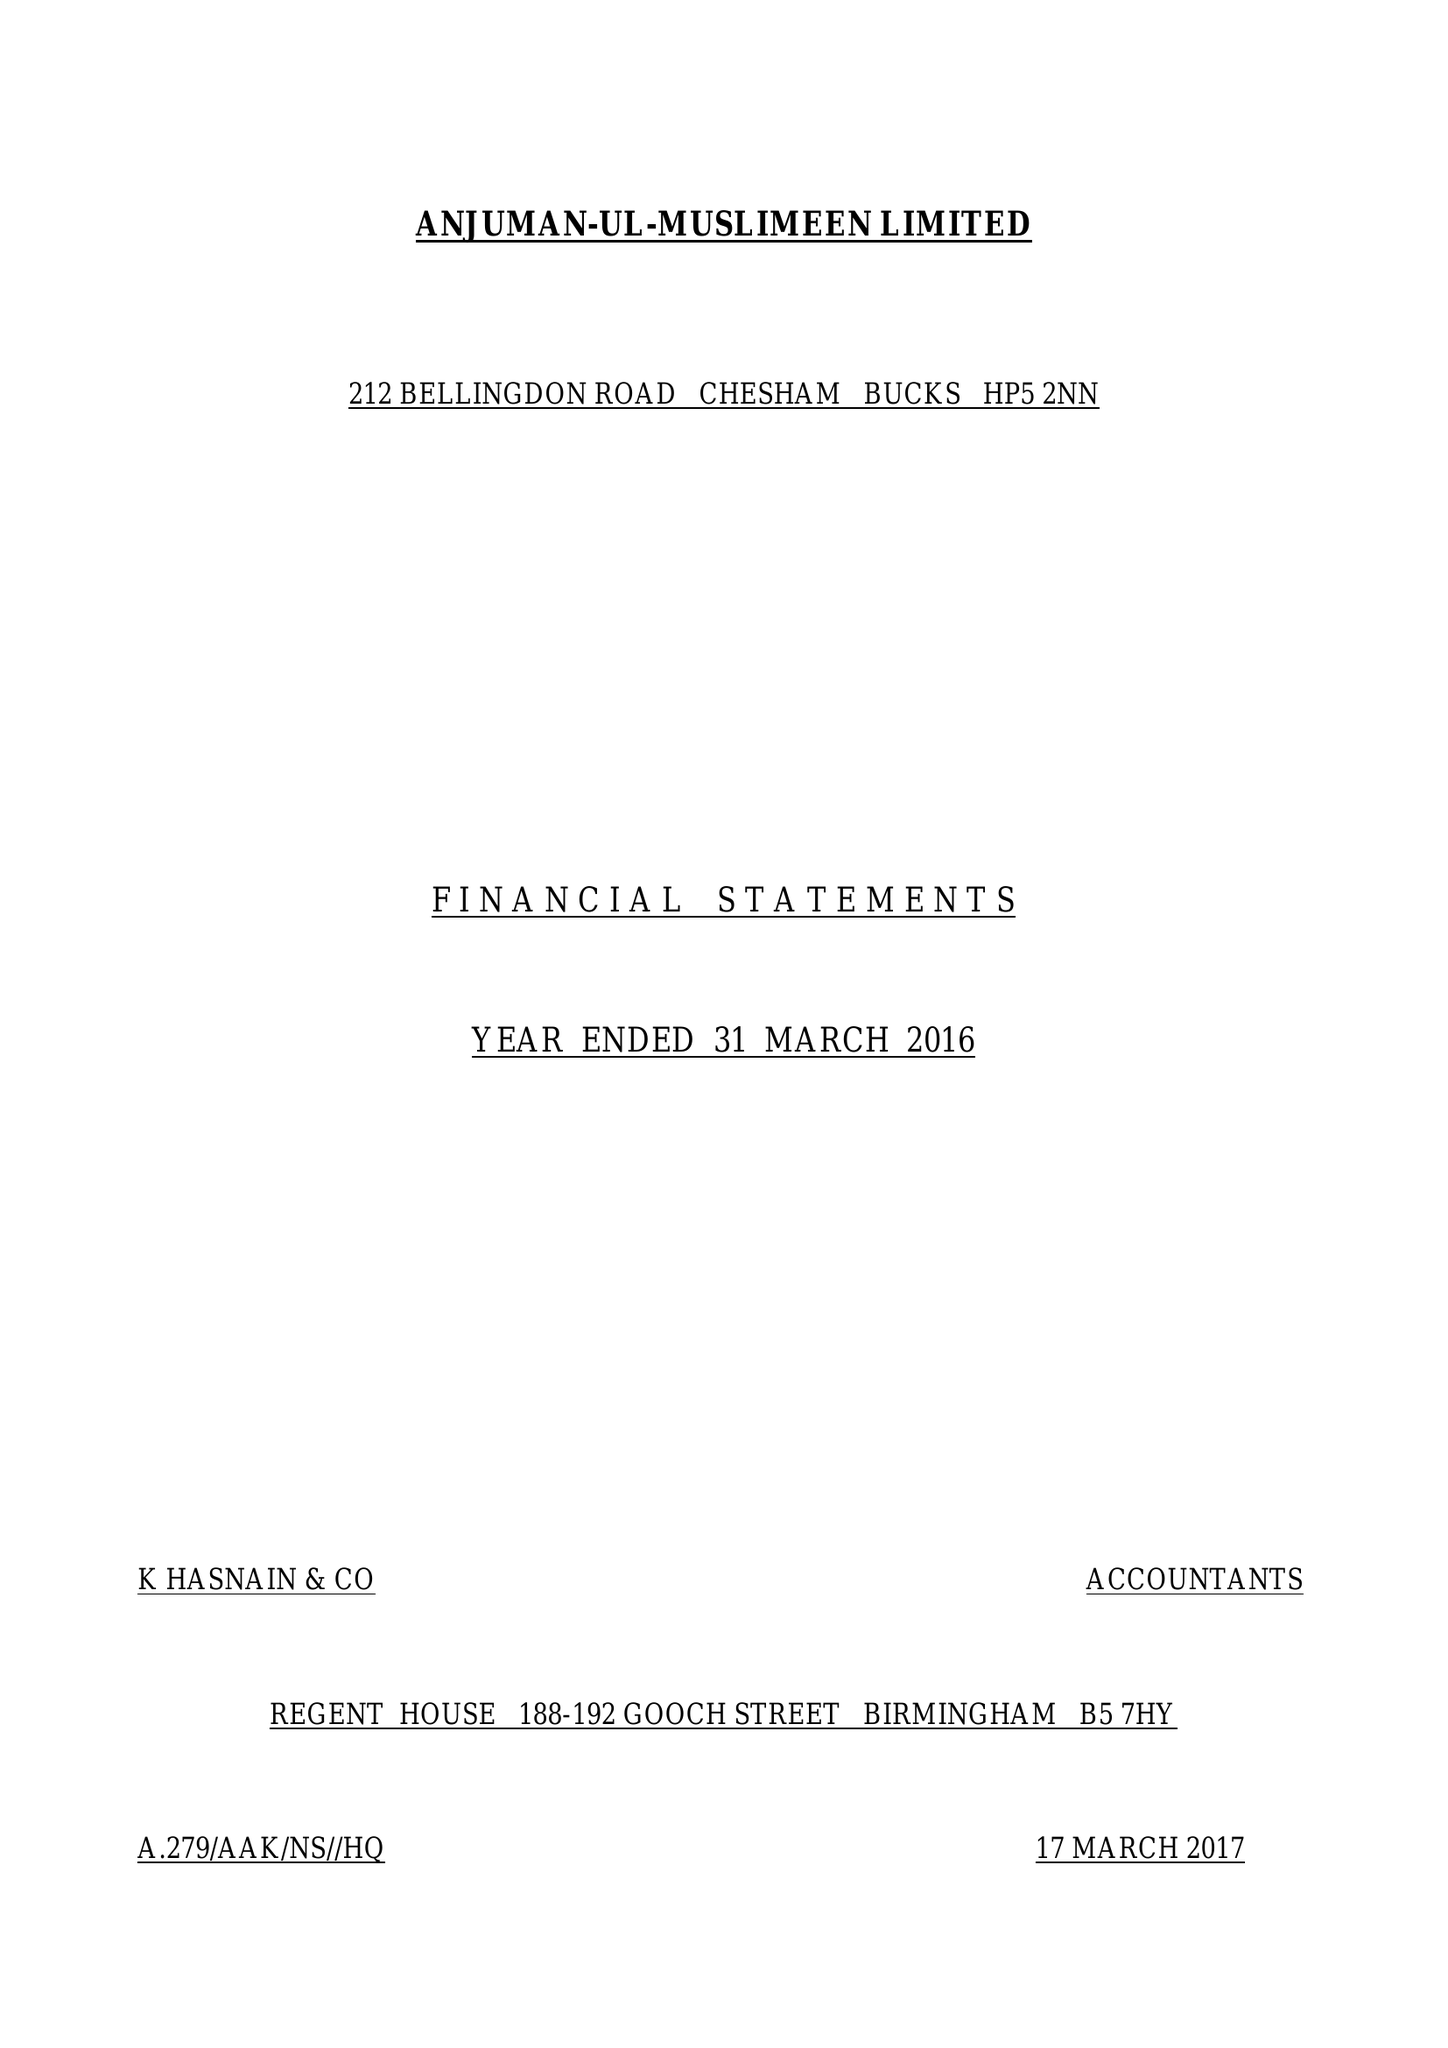What is the value for the spending_annually_in_british_pounds?
Answer the question using a single word or phrase. 77444.00 